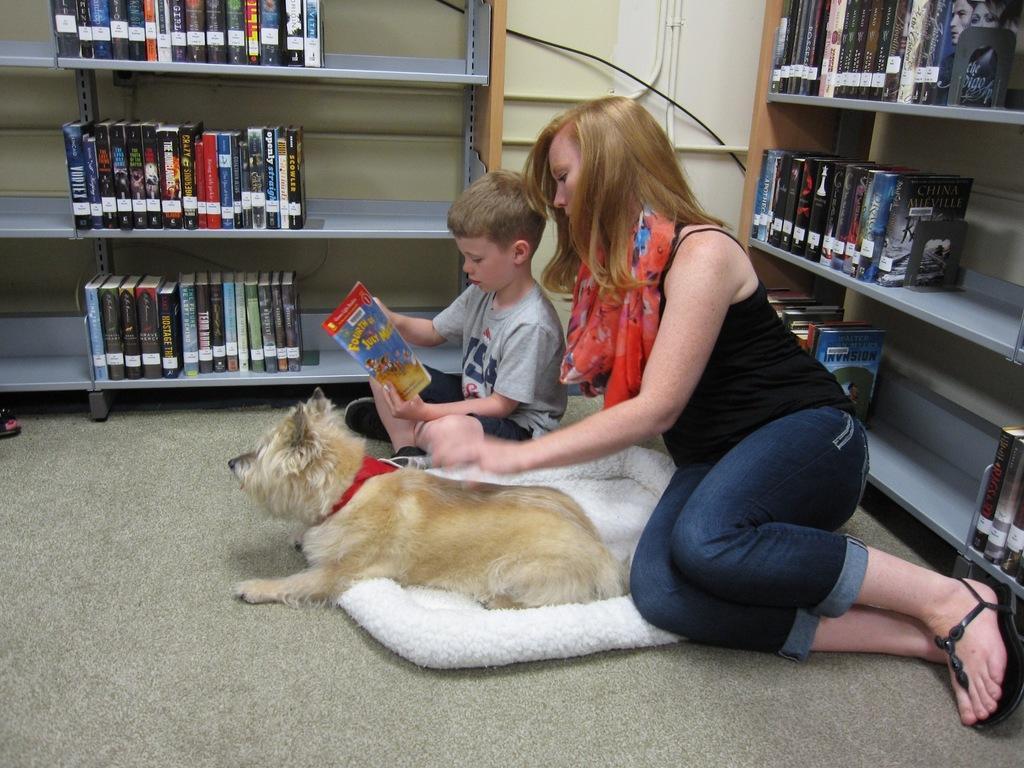Can you describe this image briefly? In this image, we can see a dog on the cloth and there is a lady and a kid holding a book. In the background, there are books in the racks and we can see some pipes and there is a wall. At the bottom, there is a floor. 